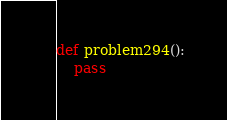Convert code to text. <code><loc_0><loc_0><loc_500><loc_500><_Python_>def problem294():
    pass
</code> 